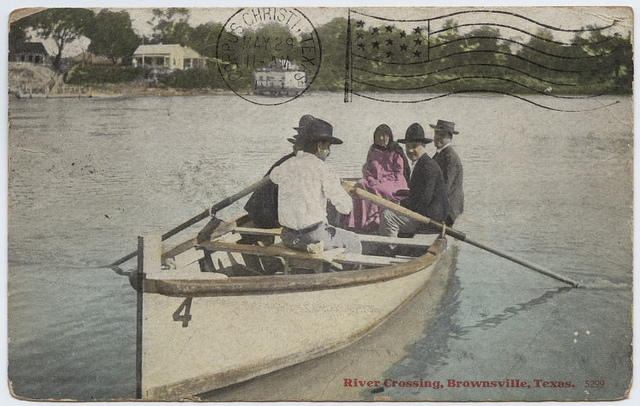Identify the text contained in this image. CHRIST 4 River Crossing Brownville, Texns 